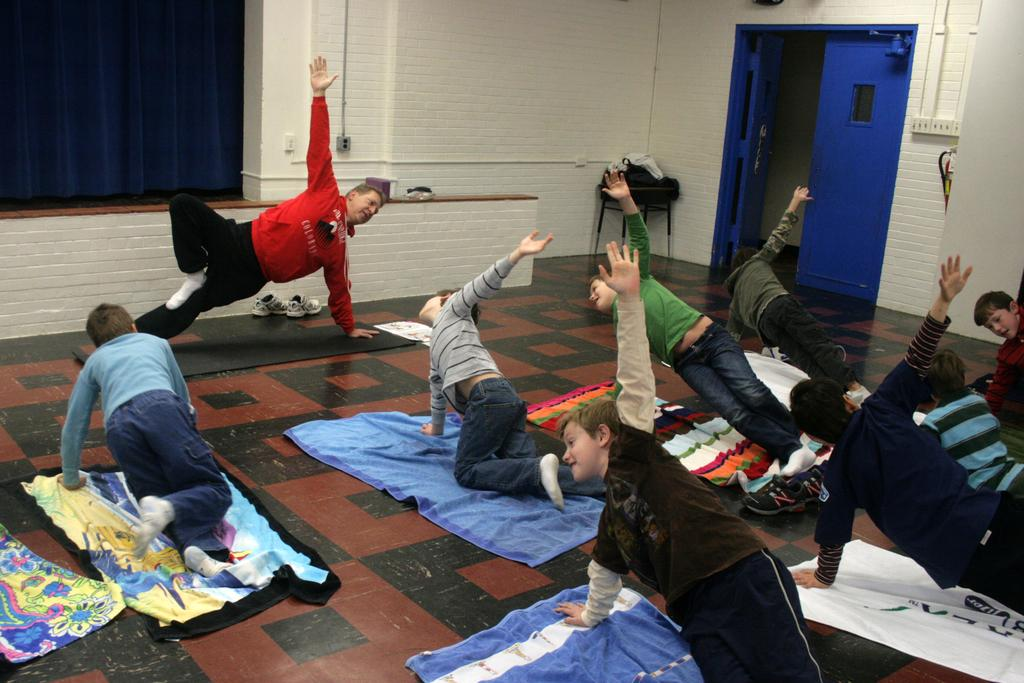What are the people in the image doing? The people in the image are doing yoga. What are the people using to perform yoga? The people are using yoga mats. What architectural feature can be seen in the image? There are doors visible in the image. What is on the stool in the image? There are objects on the stool in the image. What type of window treatment is present in the image? There is a curtain in the image. What type of structure is visible in the image? There is a wall in the image. What is the rate of the chin's curve in the image? There is no chin or curve mentioned in the image; it features people doing yoga with yoga mats. 